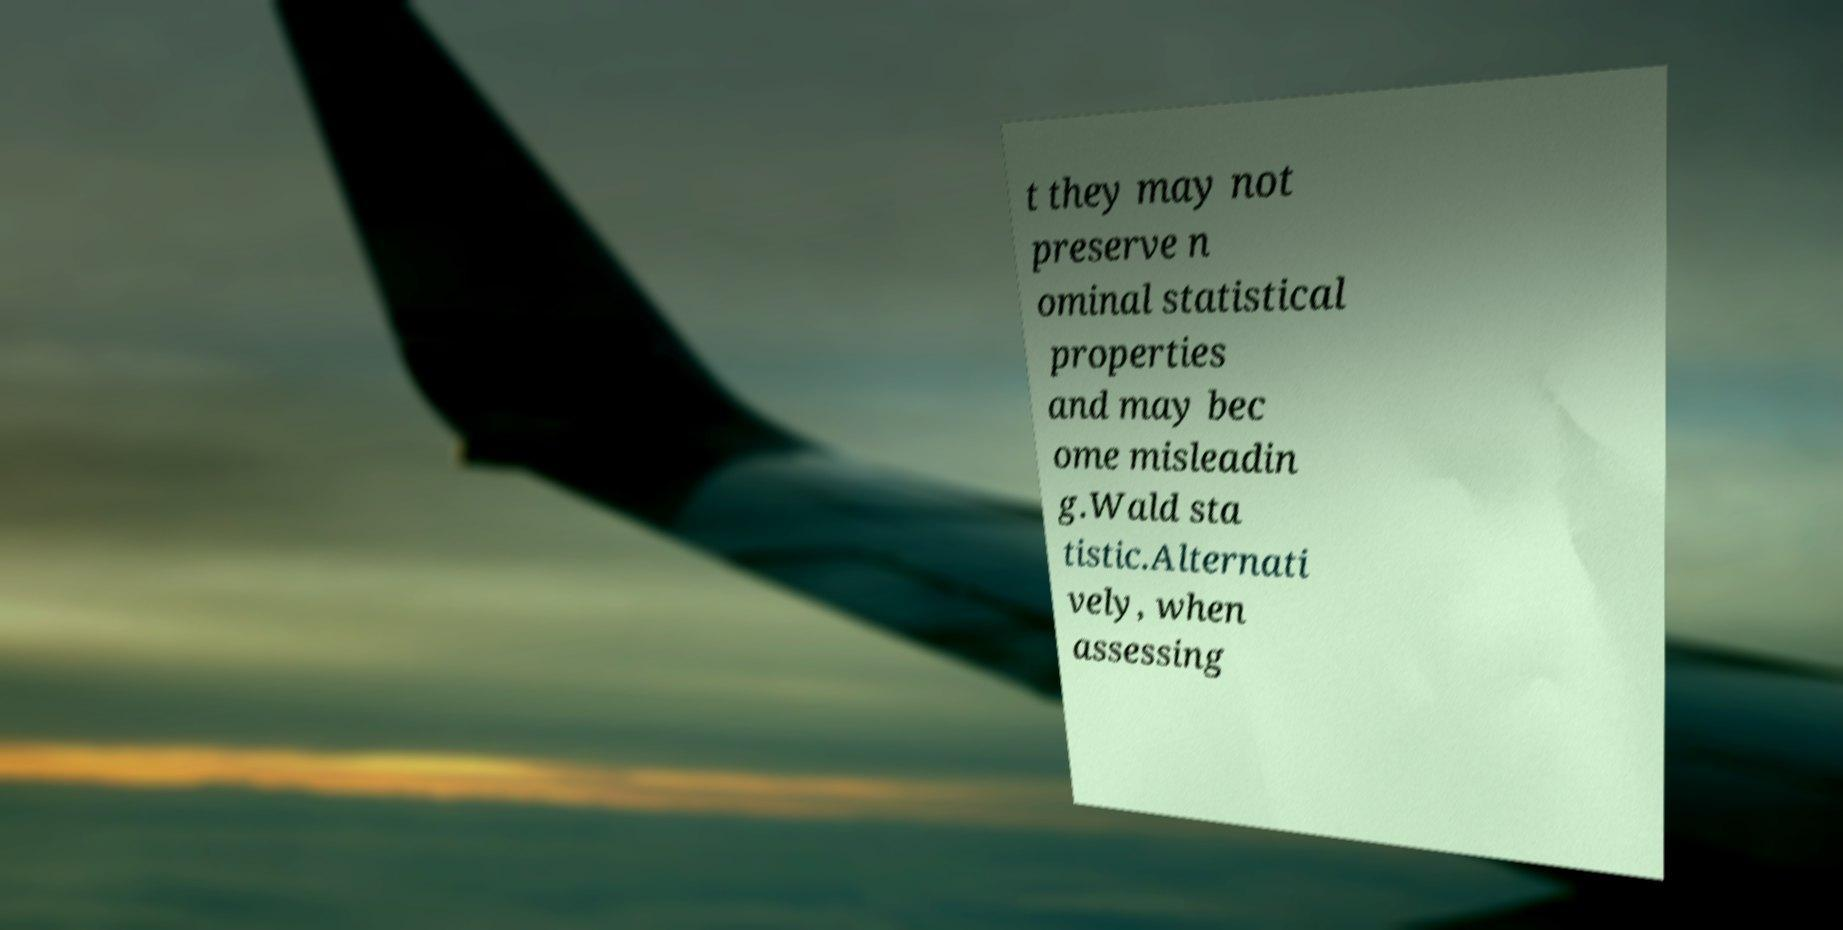What messages or text are displayed in this image? I need them in a readable, typed format. t they may not preserve n ominal statistical properties and may bec ome misleadin g.Wald sta tistic.Alternati vely, when assessing 